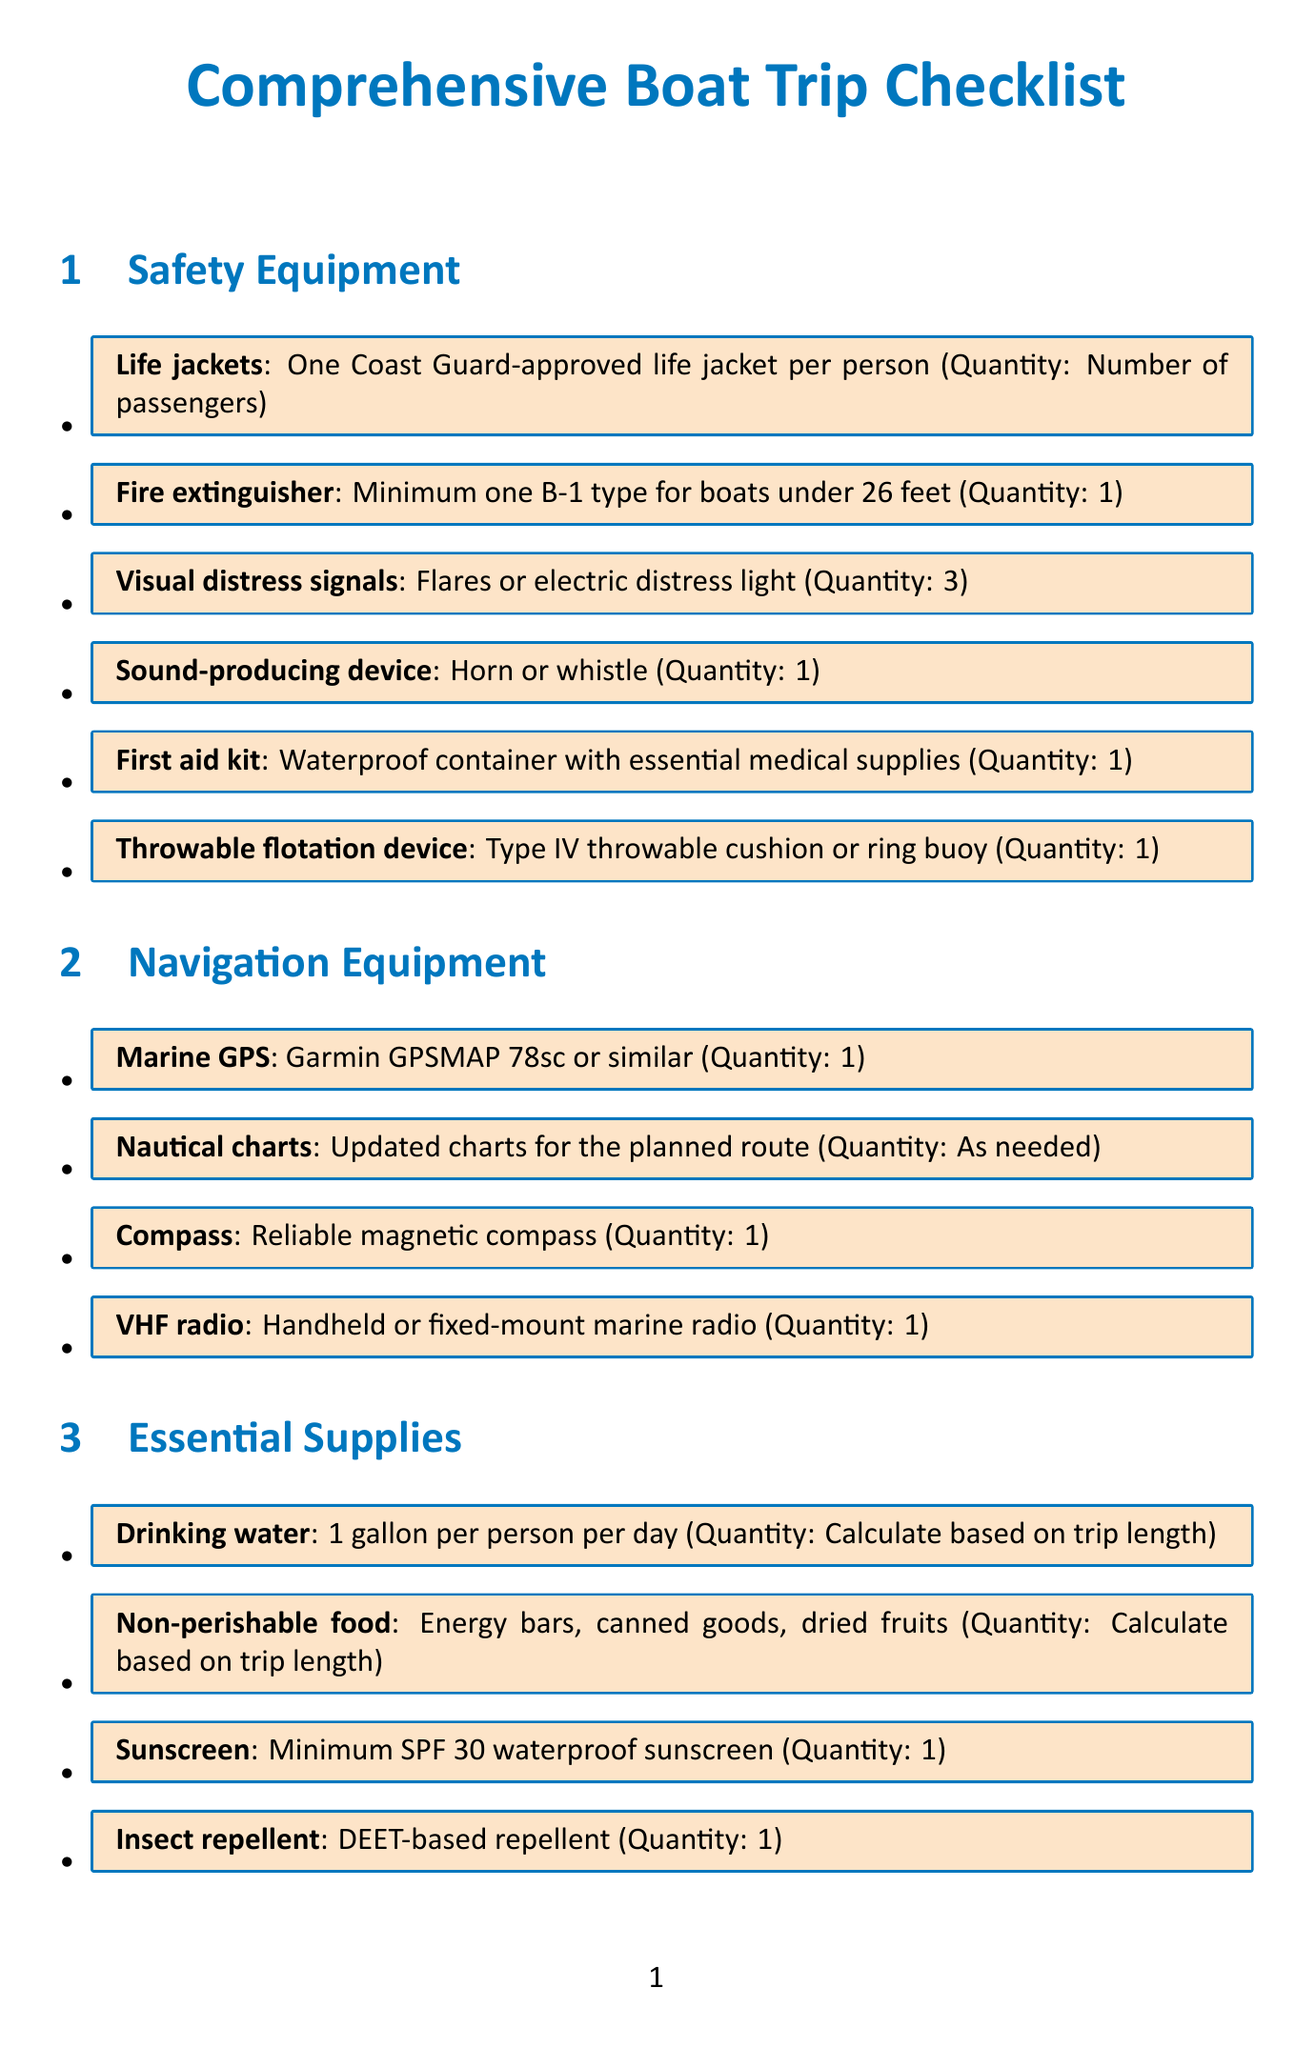What is the title of the document? The title is indicated at the top of the document and provides an overview of its content.
Answer: Comprehensive Boat Trip Checklist How many life jackets are required? The document specifies that there should be one life jacket per person, which is the number of passengers.
Answer: Number of passengers What type of marine GPS is recommended? The document lists a specific model of GPS as a suggestion for navigation.
Answer: Garmin GPSMAP 78sc or similar How many visual distress signals are needed? The checklist specifies the quantity of visual distress signals required for safety.
Answer: 3 What is the recommended quantity of drinking water per person? The document provides a guideline for the amount of drinking water to bring on the trip.
Answer: 1 gallon per person per day Why is duct tape included in the essential supplies? This item is included for a specific purpose as noted in the document.
Answer: For emergency repairs What is the recommended amount of extra fuel to carry? The document mentions the required amount of fuel including an additional percentage.
Answer: Full tank plus 20% extra What personal item is suggested for sun protection? A specific personal item is identified in the document for protection against sun exposure.
Answer: Wide-brimmed sun hat What should be done before leaving the dock? The document provides a precautionary measure that needs to be followed.
Answer: Conduct a thorough boat inspection before leaving the dock 